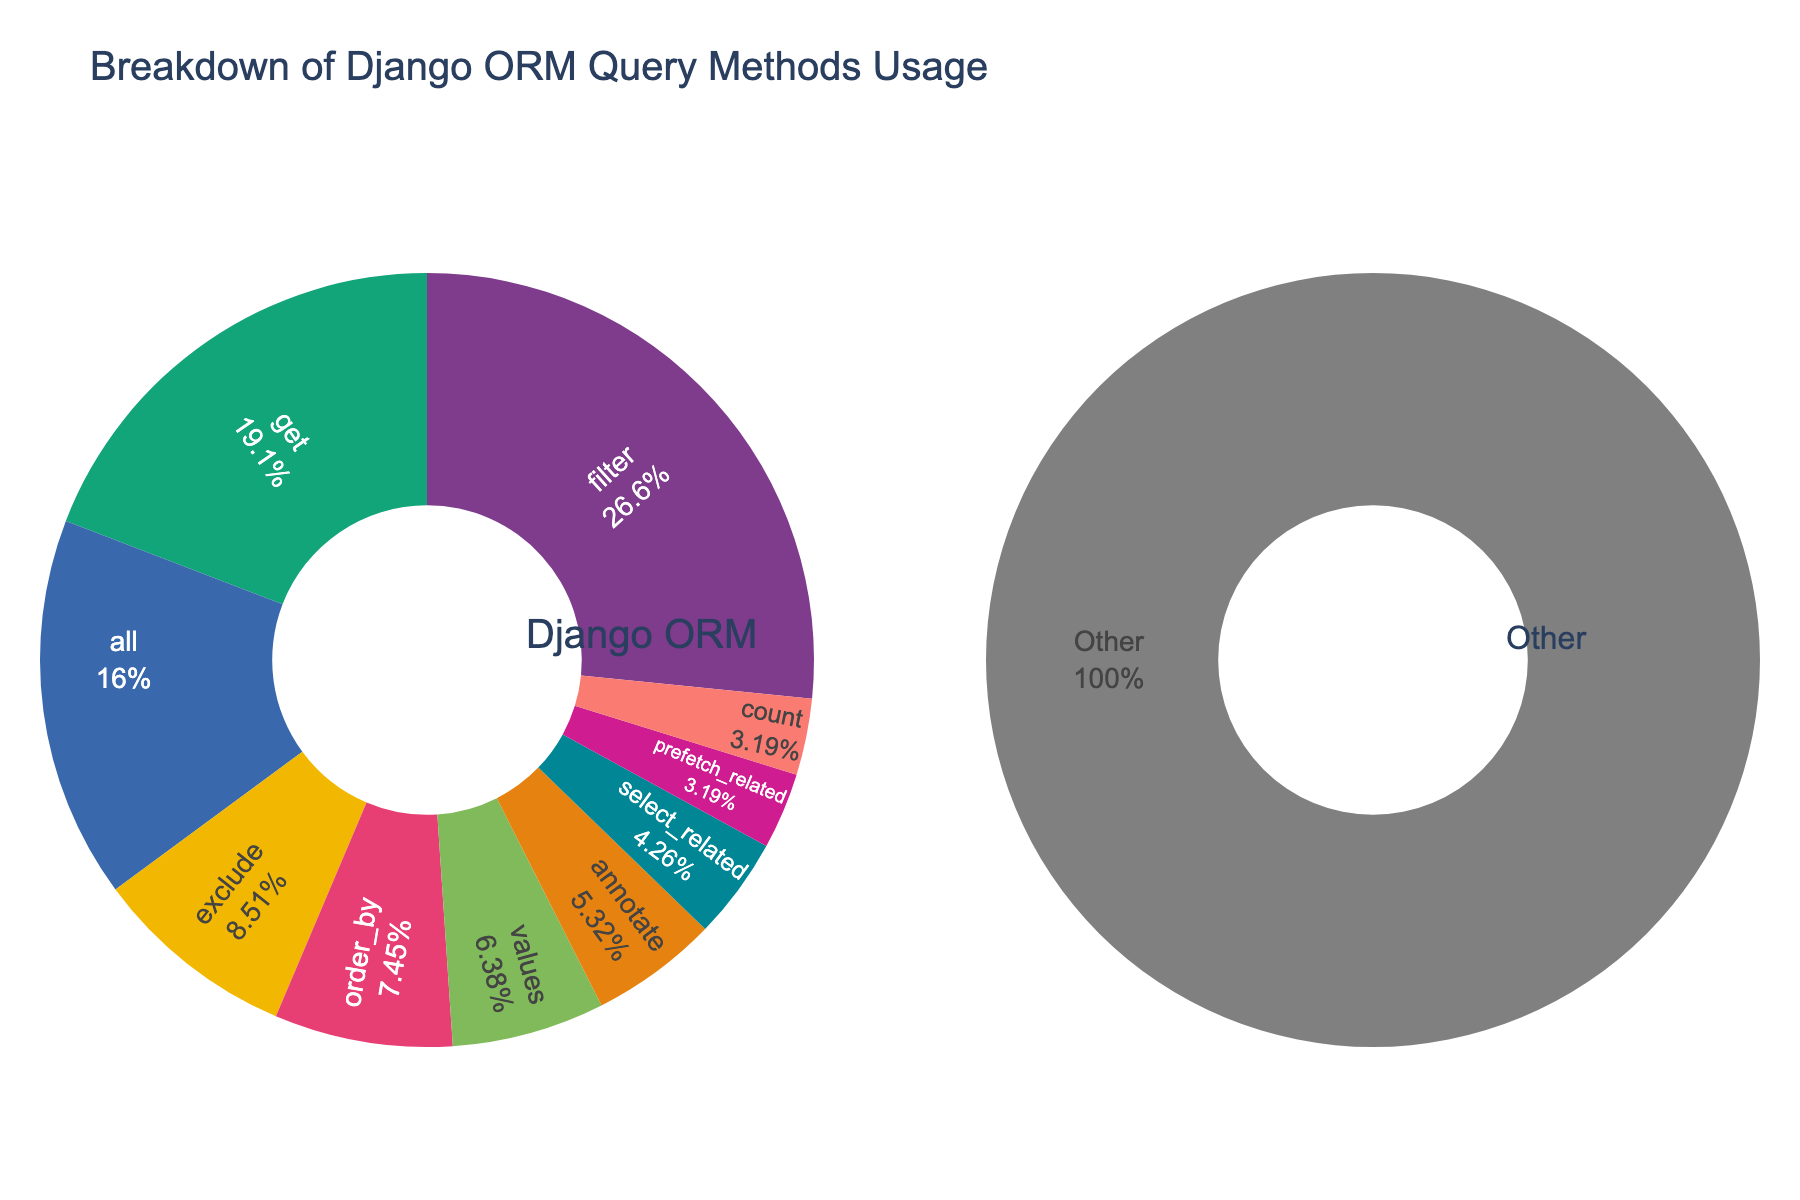What is the most frequently used Django ORM query method? The most frequently used method can be identified by looking at the largest segment in the first pie chart.
Answer: filter What is the combined percentage of methods 'get,' 'all,' and 'exclude'? Add the percentages of 'get' (18), 'all' (15), and 'exclude' (8): 18 + 15 + 8 = 41
Answer: 41% Which is used more frequently: 'order_by' or 'prefetch_related'? Compare the percentages of 'order_by' (7) and 'prefetch_related' (3). Since 7 is greater than 3, 'order_by' is used more frequently.
Answer: order_by What is the percentage difference between the 'filter' method and the 'exists' method? Subtract the percentage of 'exists' (2) from that of 'filter' (25): 25 - 2 = 23
Answer: 23% What percentage of the methods falls under the 'Other' category? The 'Other' category percentage is directly mentioned in the second pie chart. Summing up the percentages of 'Other' methods provides this value.
Answer: 12% Is the 'all' method used more often than the 'order_by' method? Compare the percentages of 'all' (15) and 'order_by' (7). Since 15 is greater than 7, 'all' is used more often.
Answer: Yes Which query method is used less often: 'count' or 'first'? Compare the percentages of 'count' (3) and 'first' (2). Since 2 is less than 3, 'first' is used less often.
Answer: first How many methods have a usage percentage of 5 or more? Identify methods with usage percentages of 5 or more: 'filter', 'get', 'all', 'exclude', 'order_by', 'values', and 'annotate'. Count them: 7 methods.
Answer: 7 What is the smallest usage percentage reported in the pie chart? The pie chart segment with the least usage represents the smallest percentage, which is 'raw', 'distinct', 'aggregate', 'delete', 'bulk_create', 'create', 'update'.
Answer: 1% 